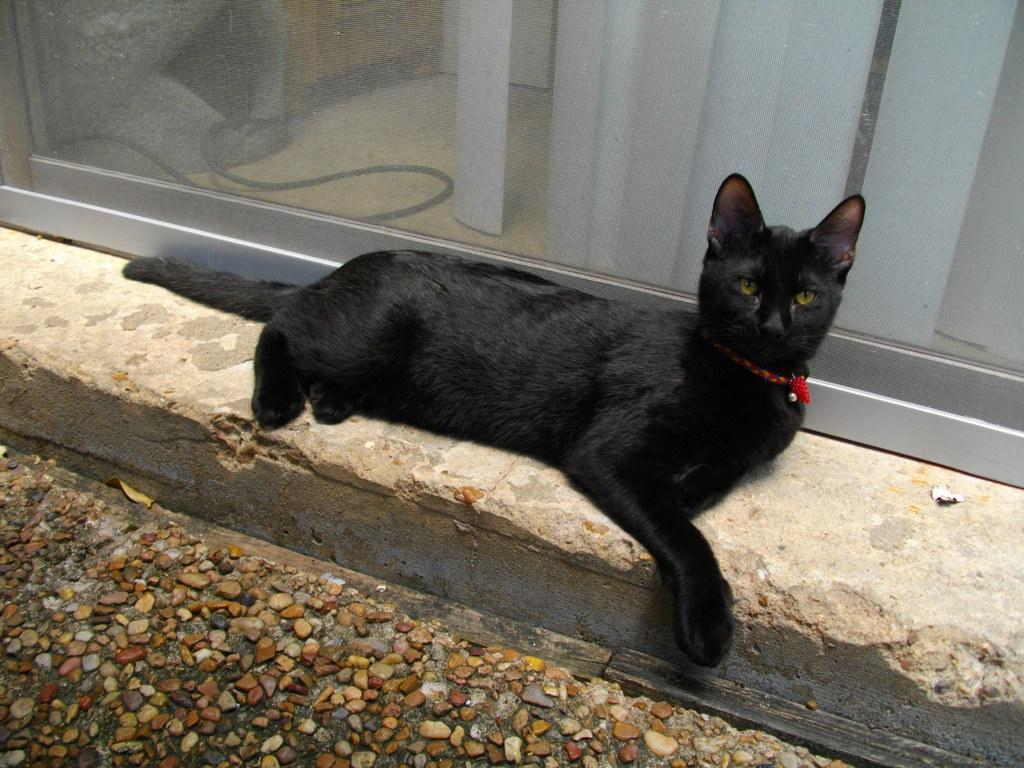What animal can be seen lying on the ground in the image? There is a cat lying on the ground in the image. What type of surface is the cat lying on? There are stones on the ground in the image. What can be seen in the background of the image? There is a glass wall in the background of the image. What is visible through the glass wall? A curtain is visible through the glass wall. What type of pie is being served to the friends in the image? There are no friends or pie present in the image; it features a cat lying on stones with a glass wall and a curtain in the background. 